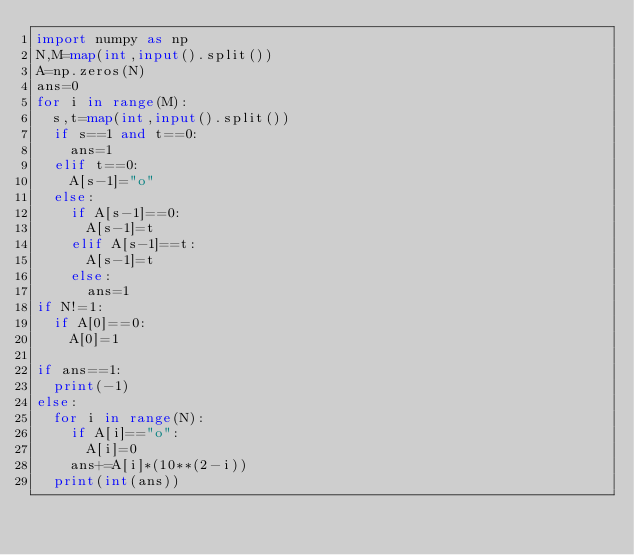<code> <loc_0><loc_0><loc_500><loc_500><_Python_>import numpy as np
N,M=map(int,input().split())
A=np.zeros(N)
ans=0
for i in range(M):
  s,t=map(int,input().split())
  if s==1 and t==0:
    ans=1
  elif t==0:
    A[s-1]="o"
  else:
    if A[s-1]==0:
      A[s-1]=t
    elif A[s-1]==t:
      A[s-1]=t
    else:
      ans=1
if N!=1:      
  if A[0]==0:
    A[0]=1

if ans==1:
  print(-1)
else:
  for i in range(N):
    if A[i]=="o":
      A[i]=0
    ans+=A[i]*(10**(2-i))
  print(int(ans))
  </code> 